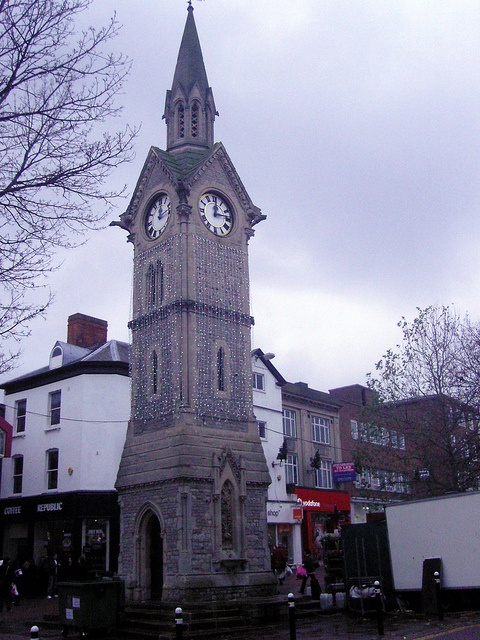Describe the objects in this image and their specific colors. I can see clock in blue, lavender, navy, and darkgray tones, clock in blue, darkgray, navy, and gray tones, people in blue, black, purple, navy, and gray tones, people in blue, black, and purple tones, and people in blue, black, purple, and navy tones in this image. 